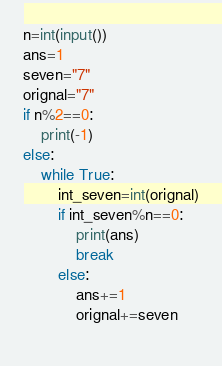Convert code to text. <code><loc_0><loc_0><loc_500><loc_500><_Python_>n=int(input())
ans=1
seven="7"
orignal="7"
if n%2==0:
    print(-1)
else:
    while True:
        int_seven=int(orignal)
        if int_seven%n==0:
            print(ans)
            break
        else:
            ans+=1
            orignal+=seven
        </code> 